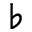<formula> <loc_0><loc_0><loc_500><loc_500>^ { \flat }</formula> 